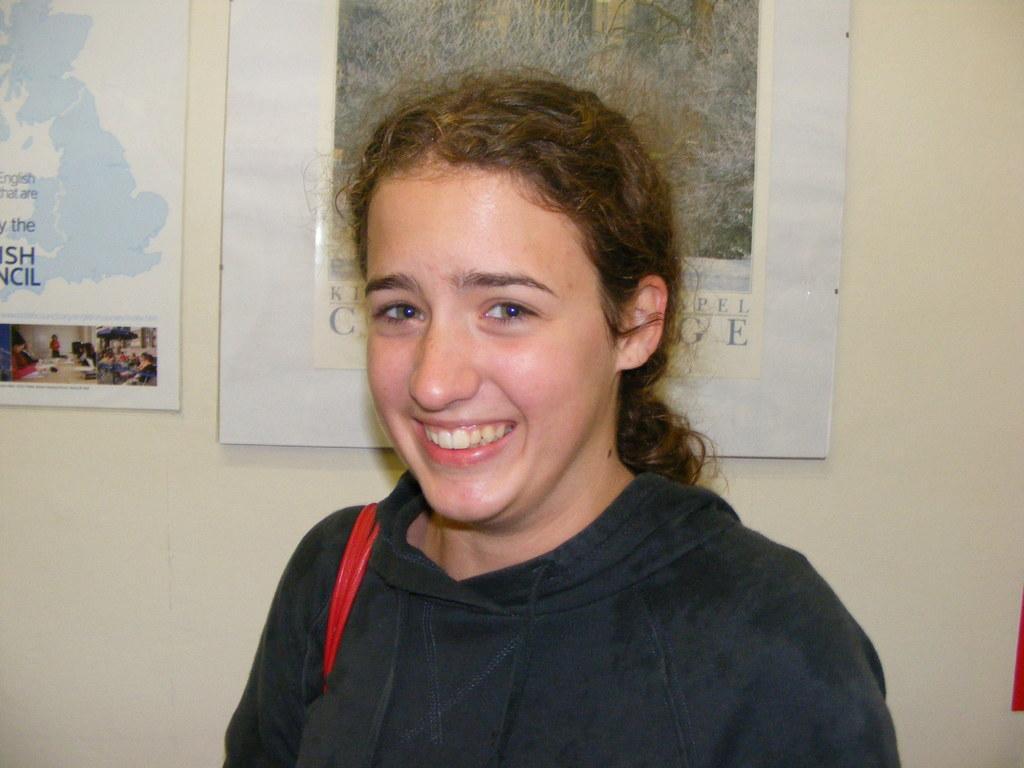Could you give a brief overview of what you see in this image? In the foreground of this picture we can see a woman smiling and standing. In the background we can see the posters containing the depictions of persons and the depictions of some other items are hanging on the wall and we can see the text on the posters. 